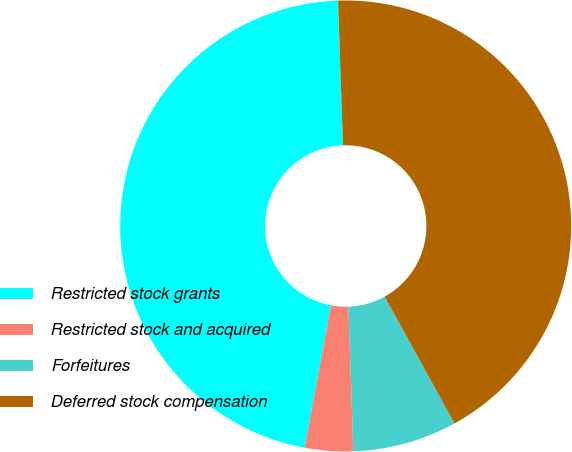Convert chart. <chart><loc_0><loc_0><loc_500><loc_500><pie_chart><fcel>Restricted stock grants<fcel>Restricted stock and acquired<fcel>Forfeitures<fcel>Deferred stock compensation<nl><fcel>46.55%<fcel>3.45%<fcel>7.48%<fcel>42.52%<nl></chart> 